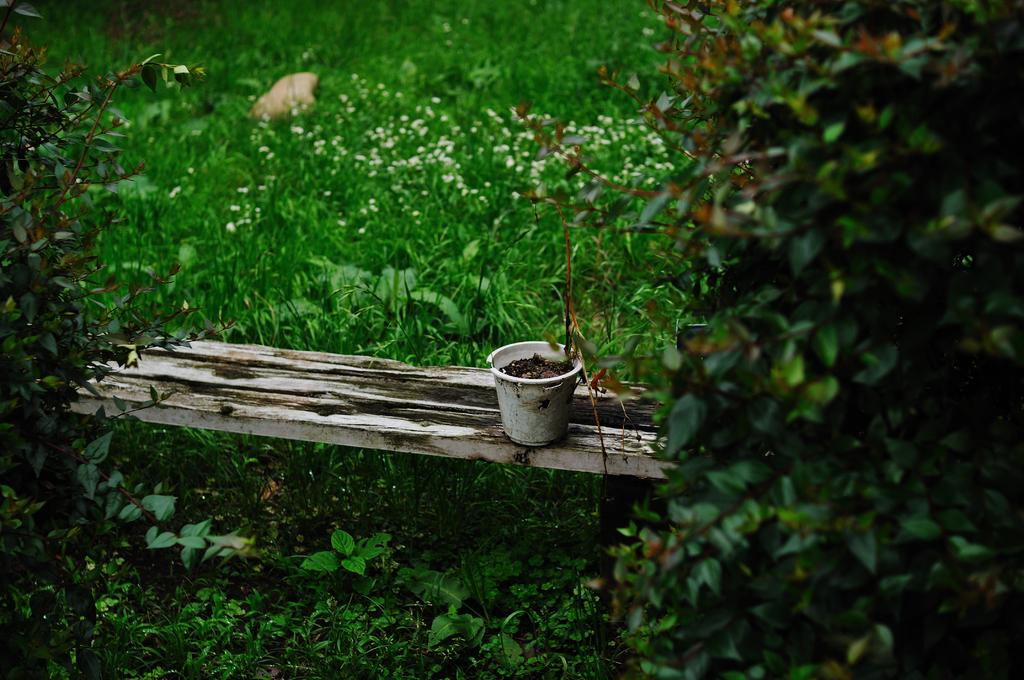What is the main object in the image? There is a flower pot in the image. What is the flower pot placed on? The flower pot is on wood. What type of living organisms can be seen in the image? There are plants in the image. What type of cake is being served to mom in the image? There is no cake or mom present in the image; it features a flower pot on wood with plants. Is there a scale visible in the image to weigh the plants? There is no scale present in the image; it only shows a flower pot on wood with plants. 